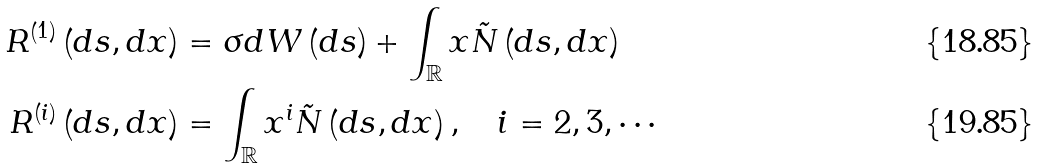Convert formula to latex. <formula><loc_0><loc_0><loc_500><loc_500>R ^ { \left ( 1 \right ) } \left ( d s , d x \right ) & = \sigma d W \left ( d s \right ) + \int _ { \mathbb { R } } x \tilde { N } \left ( d s , d x \right ) \\ R ^ { \left ( i \right ) } \left ( d s , d x \right ) & = \int _ { \mathbb { R } } x ^ { i } \tilde { N } \left ( d s , d x \right ) , \text { \ \ } i = 2 , 3 , \cdots</formula> 